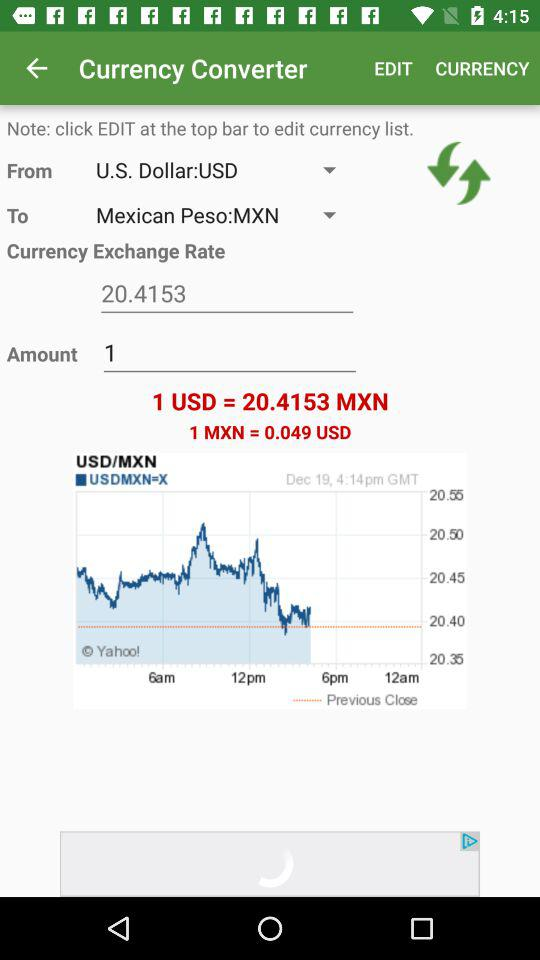What is the mentioned time? The mentioned time is 4:14 p.m. 